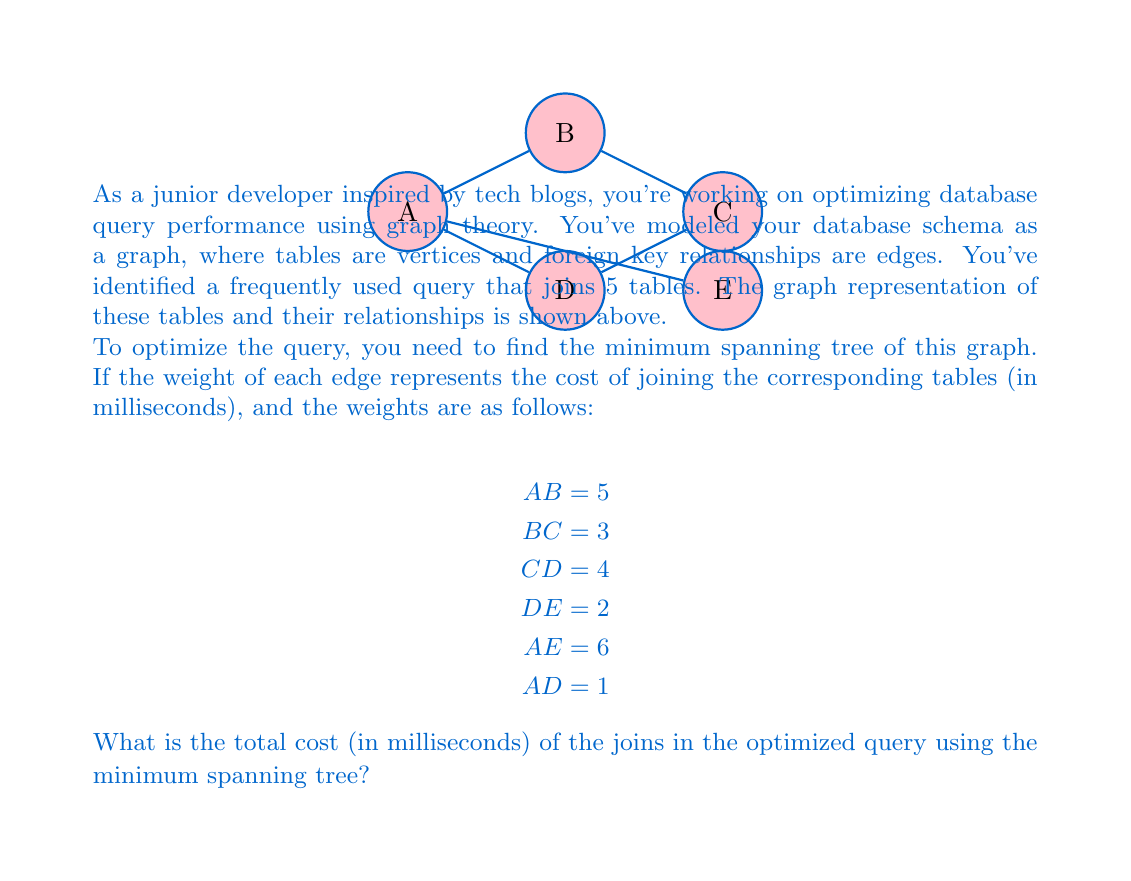What is the answer to this math problem? To solve this problem, we need to find the minimum spanning tree (MST) of the given graph. The MST will give us the optimal way to join the tables with the minimum total cost. We can use Kruskal's algorithm to find the MST:

1. Sort the edges by weight in ascending order:
   AD (1), DE (2), BC (3), CD (4), AB (5), AE (6)

2. Start with an empty set of edges and add edges in order, skipping those that would create a cycle:
   - Add AD (1)
   - Add DE (2)
   - Add BC (3)
   - Add CD (4) - skip, as it would create a cycle
   - Add AB (5) - skip, as it would create a cycle
   - Add AE (6) - skip, as it would create a cycle

3. The resulting MST consists of the edges: AD, DE, BC

4. Calculate the total cost by summing the weights of the edges in the MST:
   $$\text{Total Cost} = AD + DE + BC = 1 + 2 + 3 = 6$$

Therefore, the optimized query using the minimum spanning tree will have a total join cost of 6 milliseconds.
Answer: 6 milliseconds 